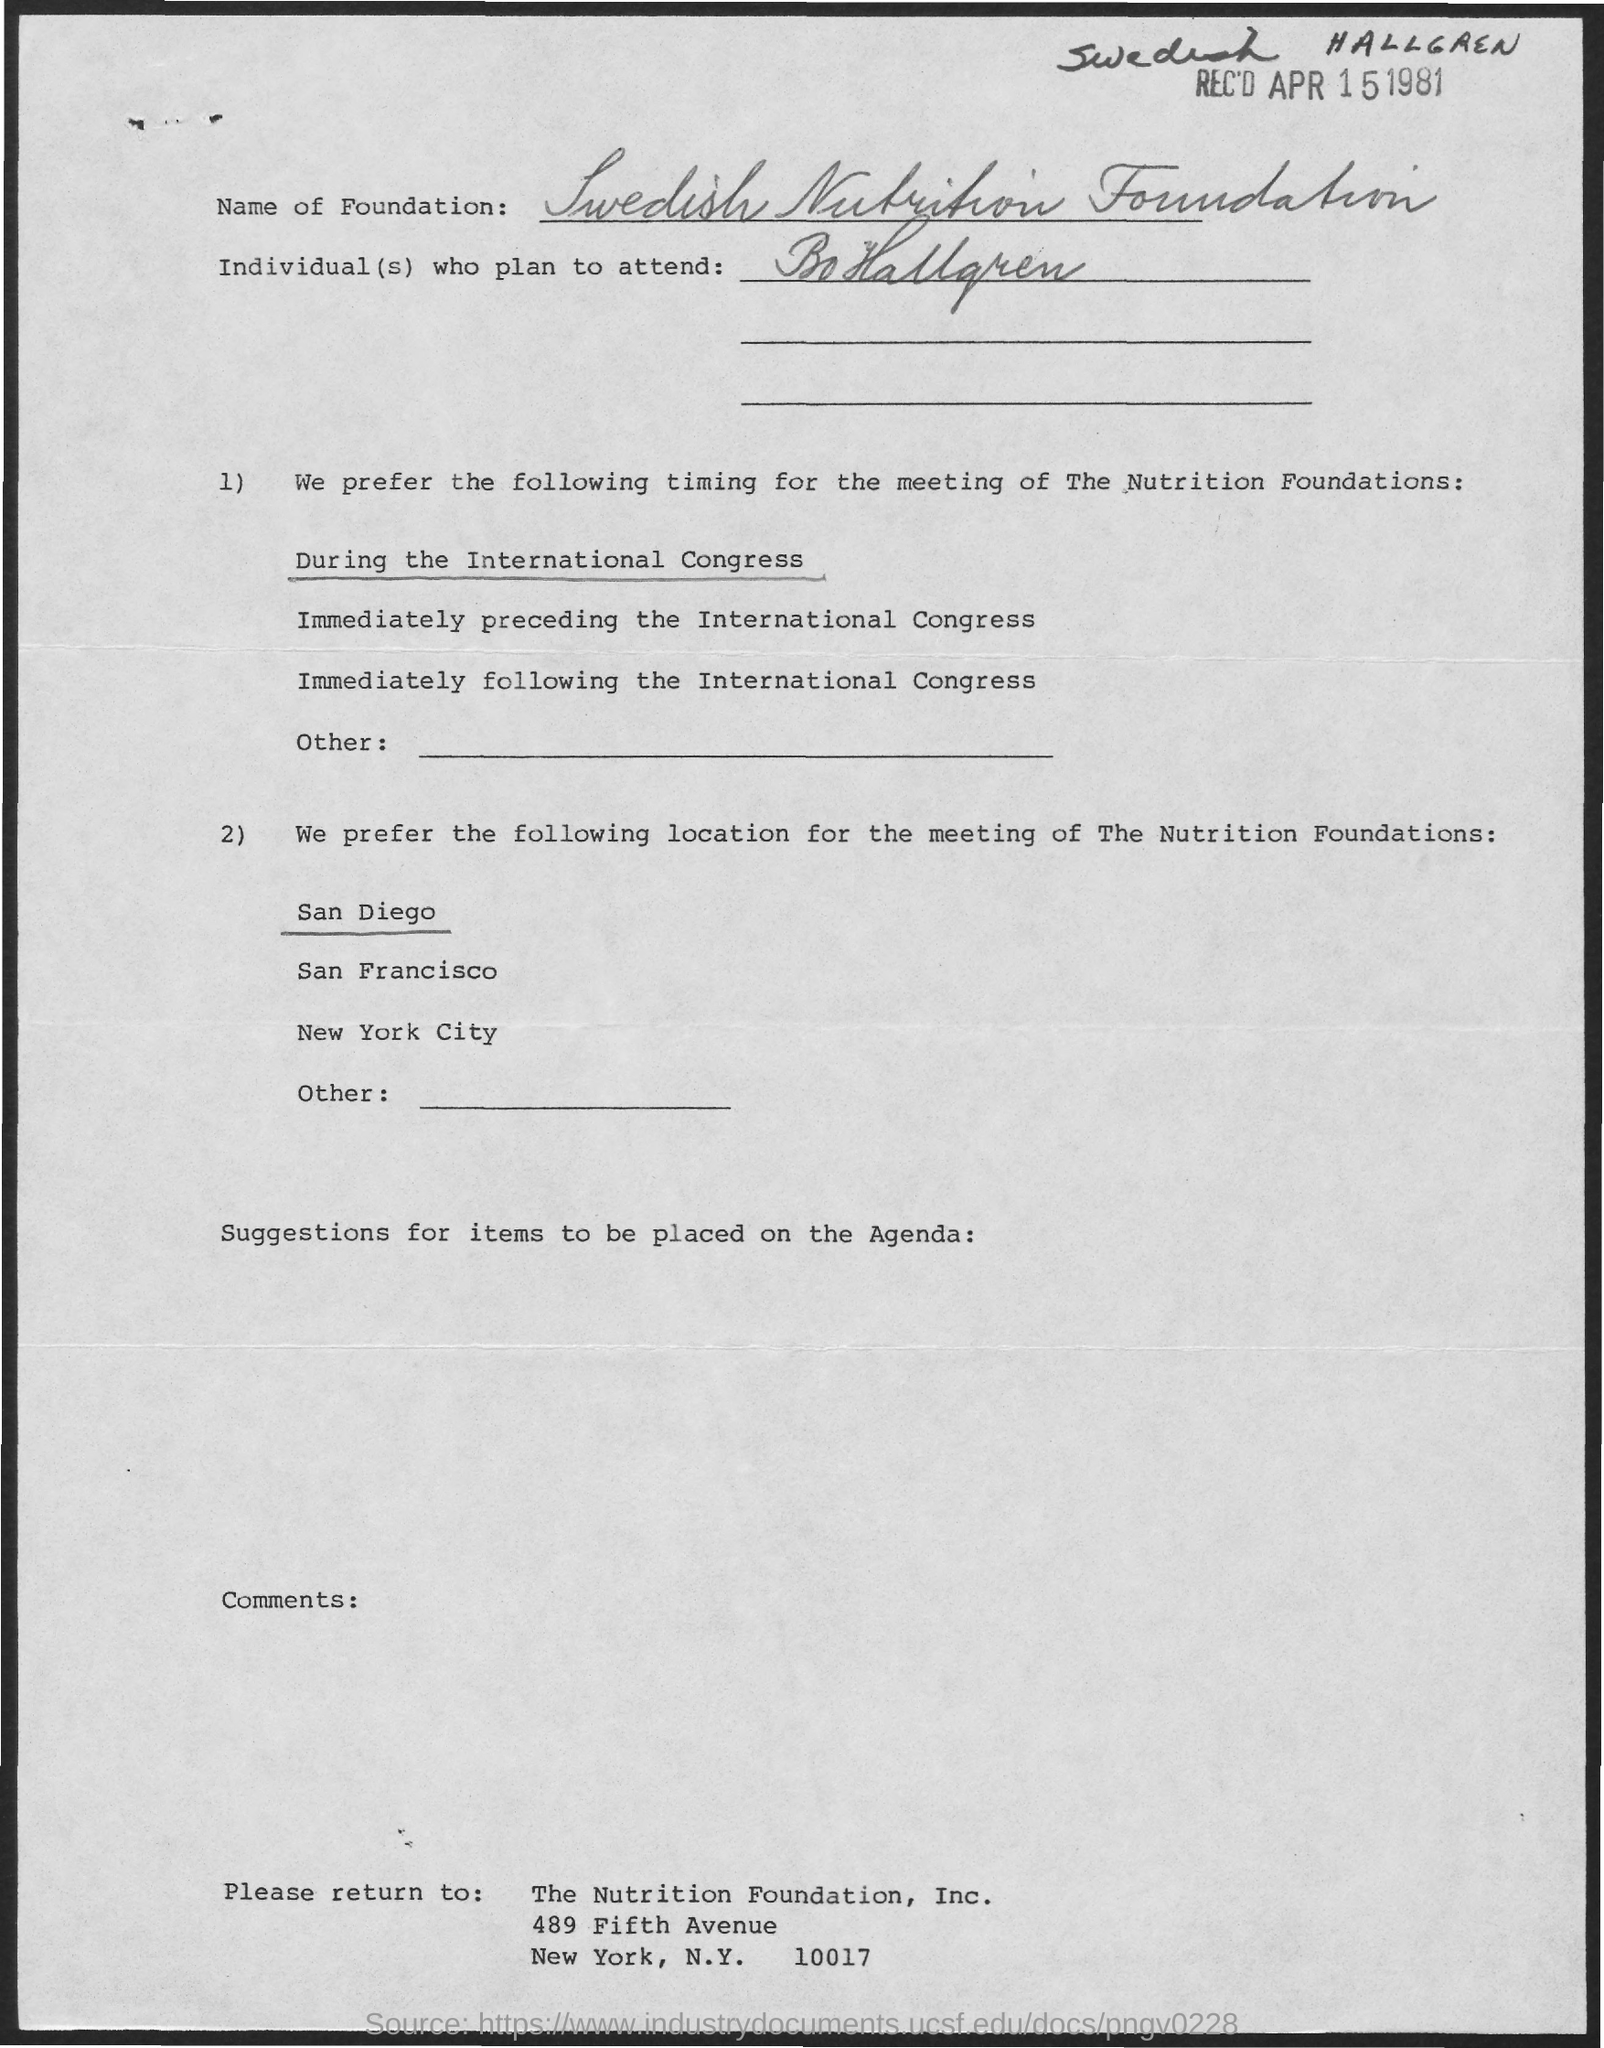Draw attention to some important aspects in this diagram. The name of the foundation is the Swedish Nutrition Foundation. On what date was the item received? 